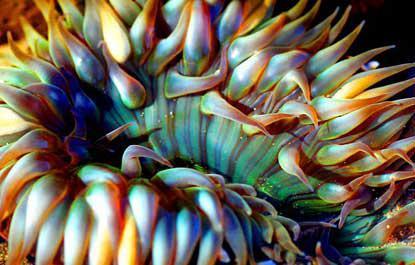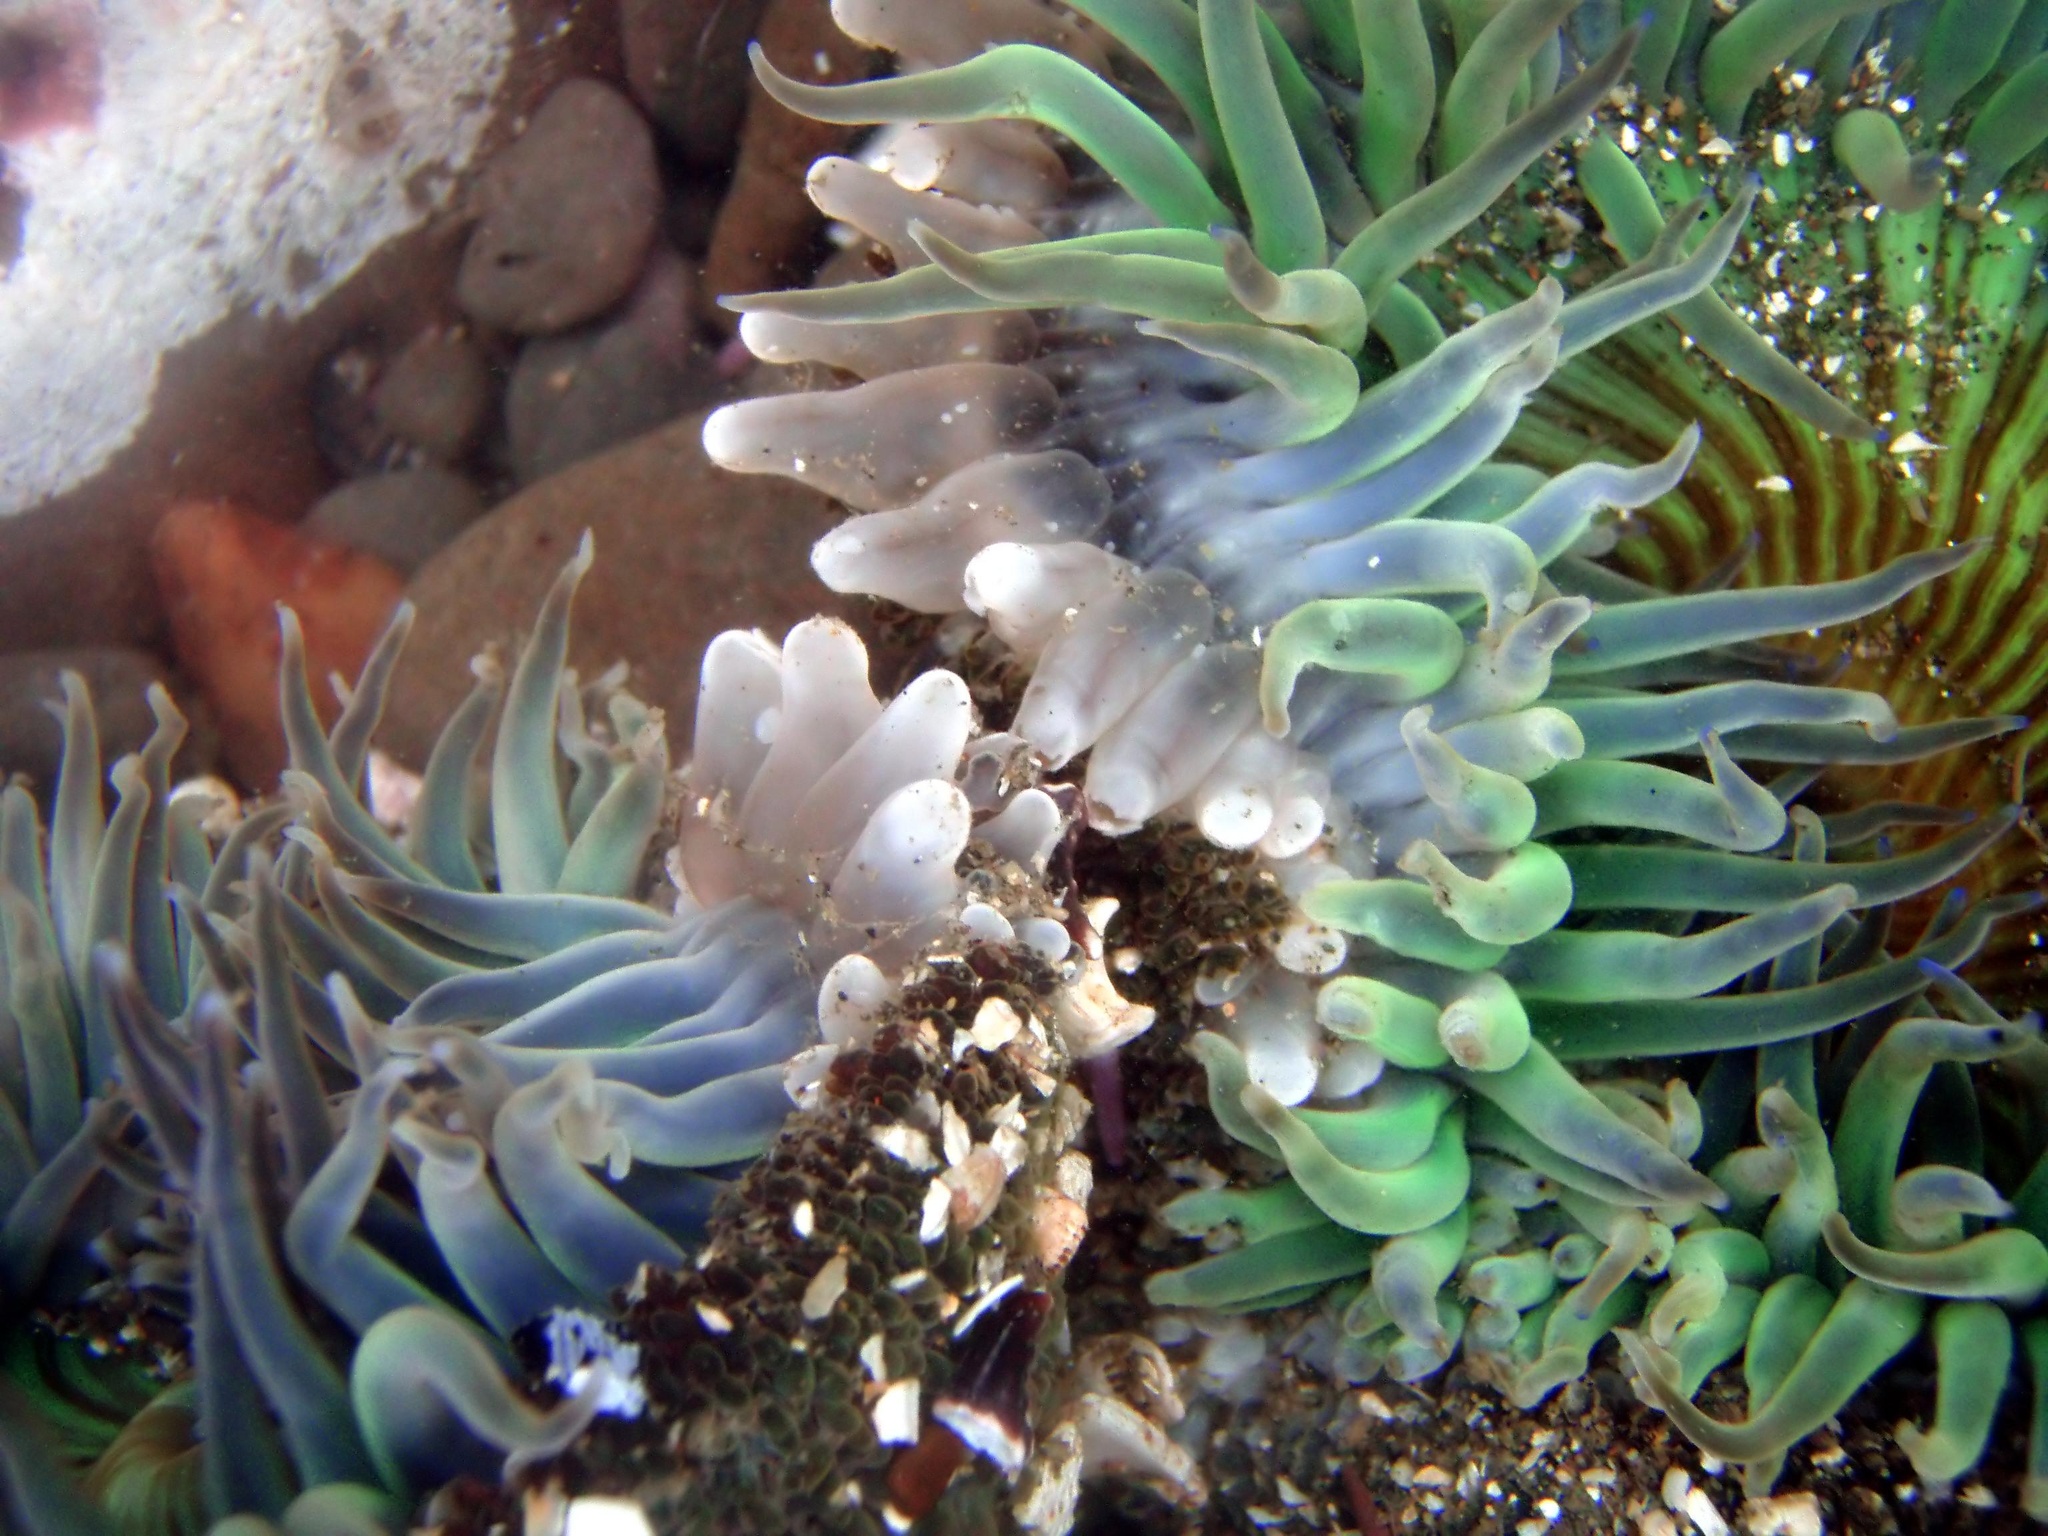The first image is the image on the left, the second image is the image on the right. For the images displayed, is the sentence "One image shows anemone tendrils sprouting from the top of a large round shape, with at least one fish swimming near it." factually correct? Answer yes or no. No. The first image is the image on the left, the second image is the image on the right. Analyze the images presented: Is the assertion "One of the anemones is spherical in shape." valid? Answer yes or no. No. 